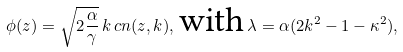Convert formula to latex. <formula><loc_0><loc_0><loc_500><loc_500>\phi ( z ) = \sqrt { 2 \frac { \alpha } { \gamma } } \, k \, c n ( z , k ) , \, \text {with} \, \lambda = \alpha ( 2 k ^ { 2 } - 1 - \kappa ^ { 2 } ) ,</formula> 